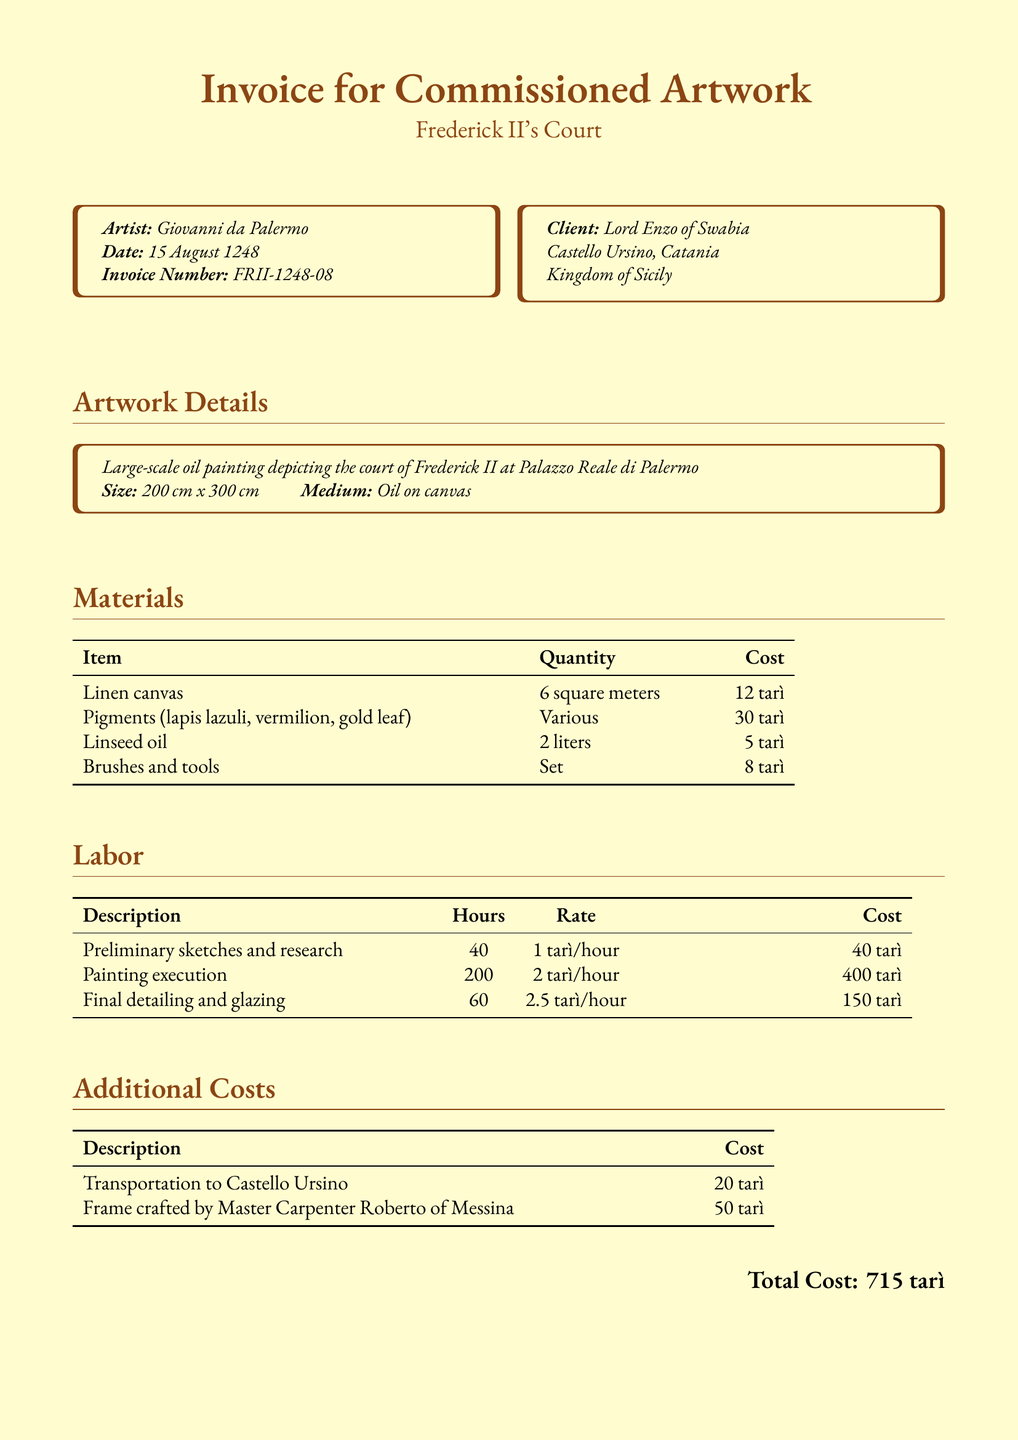What is the name of the artist? The name of the artist is clearly stated in the document.
Answer: Giovanni da Palermo When was the invoice issued? The date of the invoice is explicitly noted in the document.
Answer: 15 August 1248 What is the total cost of the commission? The total cost is summarized at the end of the document.
Answer: 715 tarì How many liters of linseed oil were required? The quantity of linseed oil needed is specified in the materials section.
Answer: 2 liters What is the hourly rate for painting execution? The rate for painting execution is found in the labor section under the relevant description.
Answer: 2 tarì/hour What medium is used for the artwork? The medium for the artwork is specified in the artwork details section.
Answer: Oil on canvas How many square meters of linen canvas were used? The quantity of linen canvas is provided in the materials section.
Answer: 6 square meters Who is the client for this commissioned artwork? The client's name and some details are mentioned at the beginning of the document.
Answer: Lord Enzo of Swabia What is the cost for the frame crafted by Master Carpenter Roberto? The cost of the frame is provided in the additional costs section.
Answer: 50 tarì 